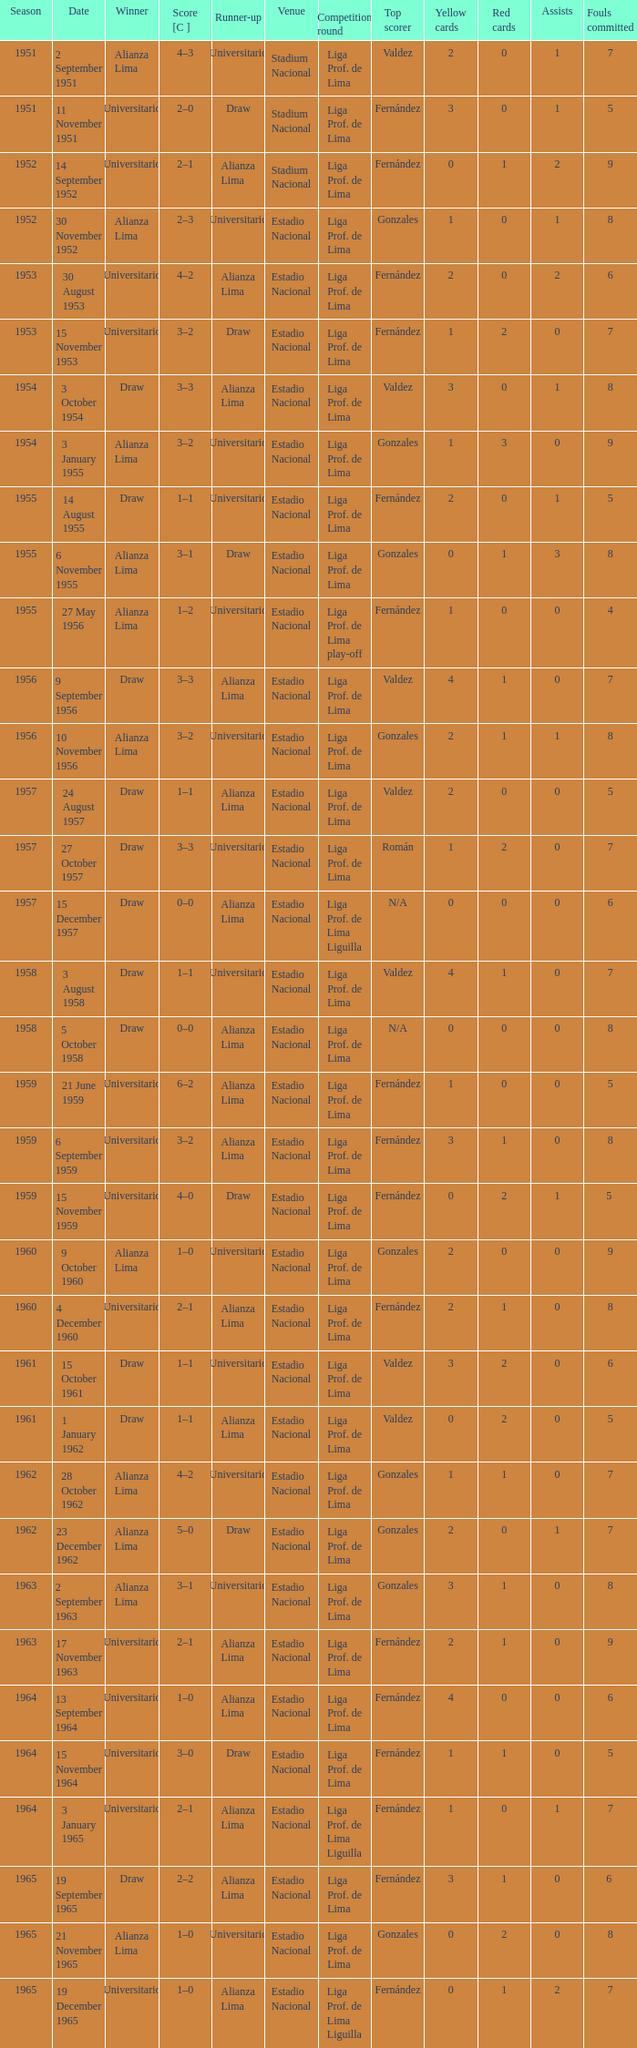What venue had an event on 17 November 1963? Estadio Nacional. 